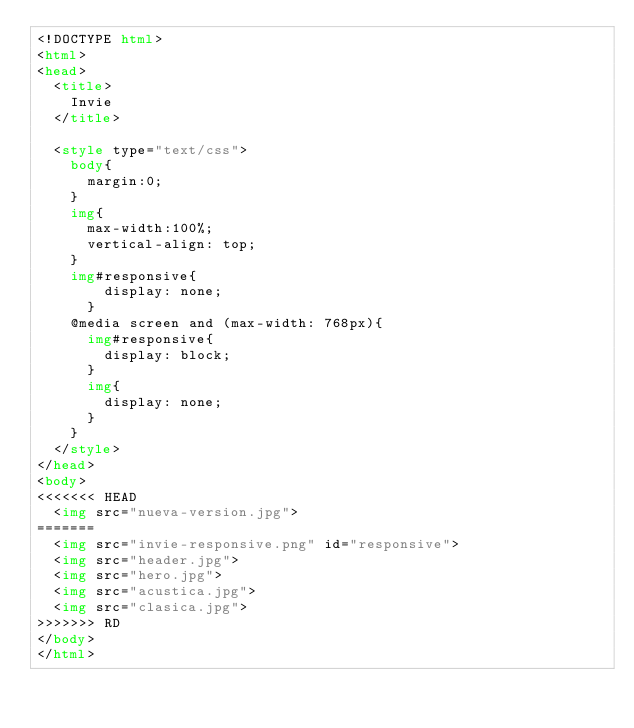Convert code to text. <code><loc_0><loc_0><loc_500><loc_500><_HTML_><!DOCTYPE html>
<html>
<head>
	<title>
		Invie
	</title>

	<style type="text/css">
		body{
			margin:0;
		}
		img{
			max-width:100%;
			vertical-align: top;
		}
		img#responsive{
				display: none;
			}
		@media screen and (max-width: 768px){
			img#responsive{
				display: block;
			}
			img{
				display: none;
			}
		}
	</style>
</head>
<body>
<<<<<<< HEAD
	<img src="nueva-version.jpg">
=======
	<img src="invie-responsive.png" id="responsive">
	<img src="header.jpg">
	<img src="hero.jpg">
	<img src="acustica.jpg">
	<img src="clasica.jpg">
>>>>>>> RD
</body>
</html></code> 